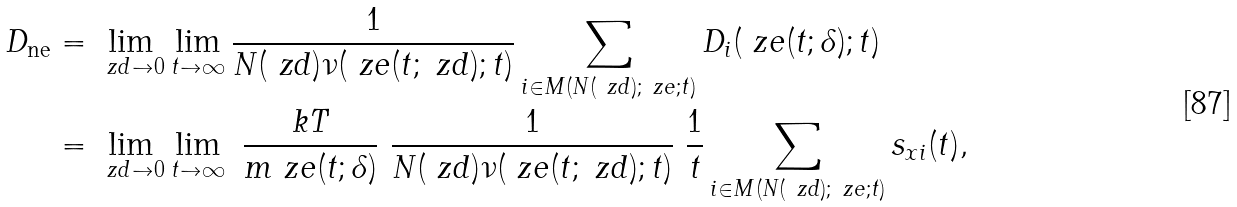<formula> <loc_0><loc_0><loc_500><loc_500>D _ { \text {ne} } & = \lim _ { \ z d \to 0 } \lim _ { t \to \infty } \frac { 1 } { N ( \ z d ) \nu ( \ z e ( t ; \ z d ) ; t ) } \sum _ { i \in M ( N ( \ z d ) ; \ z e ; t ) } D _ { i } ( \ z e ( t ; \delta ) ; t ) \\ & = \lim _ { \ z d \to 0 } \lim _ { t \to \infty } \ \frac { k T } { m \ z e ( t ; \delta ) } \ \frac { 1 } { N ( \ z d ) \nu ( \ z e ( t ; \ z d ) ; t ) } \ \frac { 1 } { t } \sum _ { i \in M ( N ( \ z d ) ; \ z e ; t ) } s _ { x i } ( t ) ,</formula> 